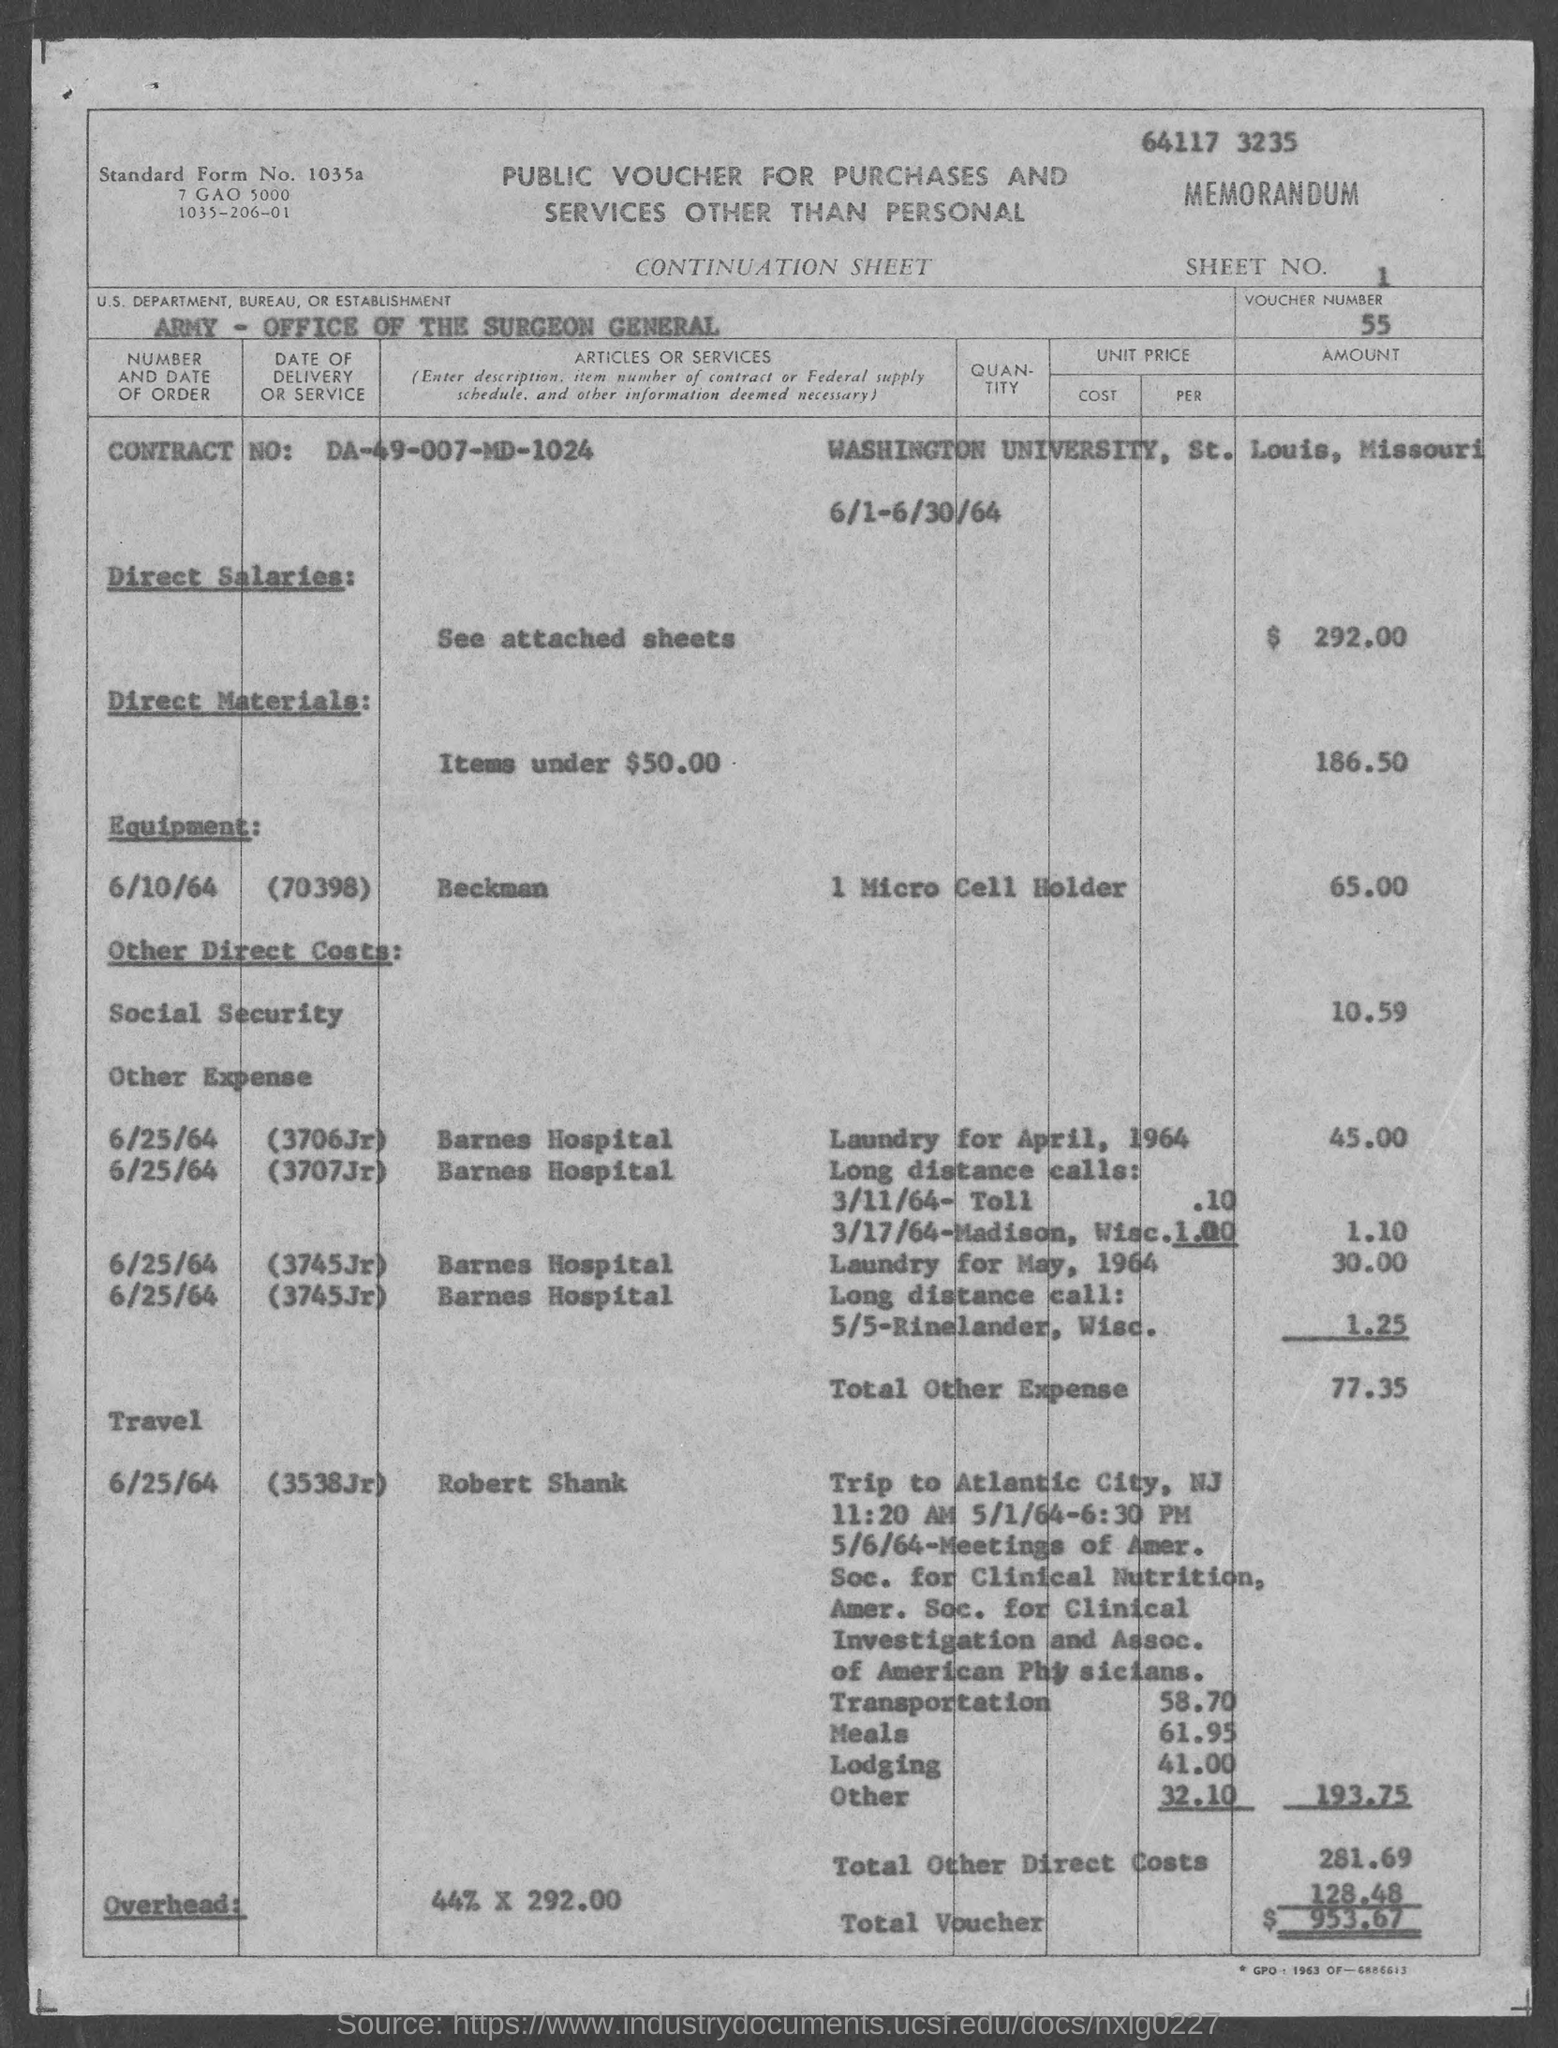What is the sheet no. mentioned in the given form ?
Offer a terse response. 1. What is the voucher number mentioned in the given form ?
Provide a succinct answer. 55. What is the contract no. mentioned in the given page ?
Make the answer very short. DA-49-007-MD-1024. What is the amount of total other expenses mentioned in the given form ?
Make the answer very short. 77.35. What is the amount of laundry for april, 1964 as mentioned in the given form ?
Make the answer very short. 45.00. What is the amount of direct salaries as mentioned in the given form ?
Make the answer very short. 292.00. What is the amount for direct materials as mentioned in the given form ?
Your answer should be very brief. $ 186.50. What is the amount for equipment as mentioned in the given form ?
Offer a terse response. 65.00. What is the amount of total voucher as mentioned in the given form ?
Offer a very short reply. 953.67. 